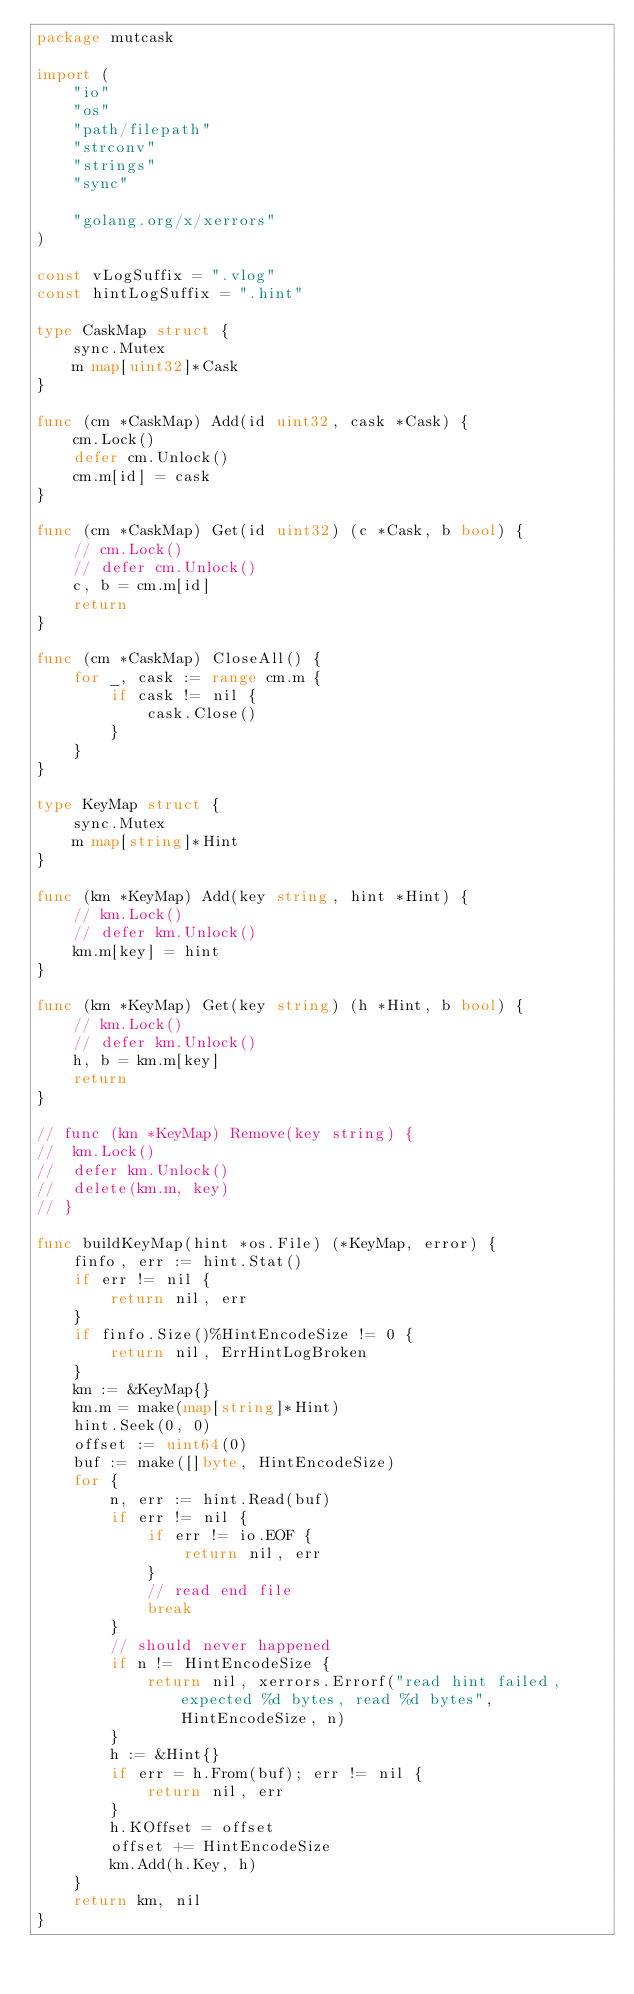<code> <loc_0><loc_0><loc_500><loc_500><_Go_>package mutcask

import (
	"io"
	"os"
	"path/filepath"
	"strconv"
	"strings"
	"sync"

	"golang.org/x/xerrors"
)

const vLogSuffix = ".vlog"
const hintLogSuffix = ".hint"

type CaskMap struct {
	sync.Mutex
	m map[uint32]*Cask
}

func (cm *CaskMap) Add(id uint32, cask *Cask) {
	cm.Lock()
	defer cm.Unlock()
	cm.m[id] = cask
}

func (cm *CaskMap) Get(id uint32) (c *Cask, b bool) {
	// cm.Lock()
	// defer cm.Unlock()
	c, b = cm.m[id]
	return
}

func (cm *CaskMap) CloseAll() {
	for _, cask := range cm.m {
		if cask != nil {
			cask.Close()
		}
	}
}

type KeyMap struct {
	sync.Mutex
	m map[string]*Hint
}

func (km *KeyMap) Add(key string, hint *Hint) {
	// km.Lock()
	// defer km.Unlock()
	km.m[key] = hint
}

func (km *KeyMap) Get(key string) (h *Hint, b bool) {
	// km.Lock()
	// defer km.Unlock()
	h, b = km.m[key]
	return
}

// func (km *KeyMap) Remove(key string) {
// 	km.Lock()
// 	defer km.Unlock()
// 	delete(km.m, key)
// }

func buildKeyMap(hint *os.File) (*KeyMap, error) {
	finfo, err := hint.Stat()
	if err != nil {
		return nil, err
	}
	if finfo.Size()%HintEncodeSize != 0 {
		return nil, ErrHintLogBroken
	}
	km := &KeyMap{}
	km.m = make(map[string]*Hint)
	hint.Seek(0, 0)
	offset := uint64(0)
	buf := make([]byte, HintEncodeSize)
	for {
		n, err := hint.Read(buf)
		if err != nil {
			if err != io.EOF {
				return nil, err
			}
			// read end file
			break
		}
		// should never happened
		if n != HintEncodeSize {
			return nil, xerrors.Errorf("read hint failed, expected %d bytes, read %d bytes", HintEncodeSize, n)
		}
		h := &Hint{}
		if err = h.From(buf); err != nil {
			return nil, err
		}
		h.KOffset = offset
		offset += HintEncodeSize
		km.Add(h.Key, h)
	}
	return km, nil
}
</code> 